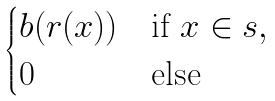<formula> <loc_0><loc_0><loc_500><loc_500>\begin{cases} b ( r ( x ) ) & \text {if } x \in s , \\ 0 & \text {else} \end{cases}</formula> 